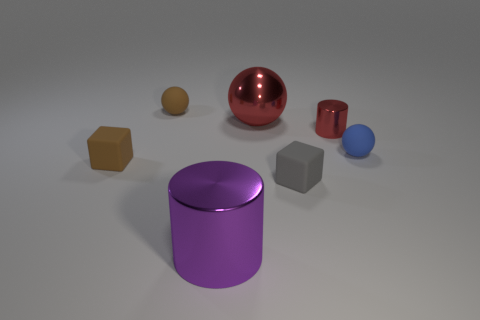There is a tiny blue object that is the same shape as the big red metal thing; what is its material?
Ensure brevity in your answer.  Rubber. What is the shape of the tiny gray thing that is made of the same material as the blue sphere?
Offer a very short reply. Cube. What material is the brown thing that is to the left of the brown ball?
Offer a terse response. Rubber. Do the rubber sphere that is to the left of the big red thing and the rubber object in front of the tiny brown block have the same size?
Your answer should be very brief. Yes. The big metallic cylinder has what color?
Offer a very short reply. Purple. There is a large object that is behind the purple metal thing; is its shape the same as the blue rubber thing?
Your response must be concise. Yes. What is the gray cube made of?
Your answer should be very brief. Rubber. There is a metal thing that is the same size as the blue matte thing; what is its shape?
Offer a terse response. Cylinder. Are there any cylinders of the same color as the big sphere?
Make the answer very short. Yes. There is a shiny ball; does it have the same color as the metallic object on the left side of the big red metallic ball?
Your answer should be compact. No. 